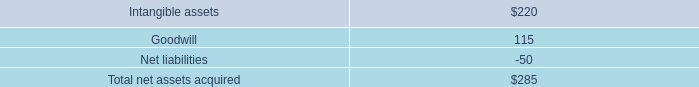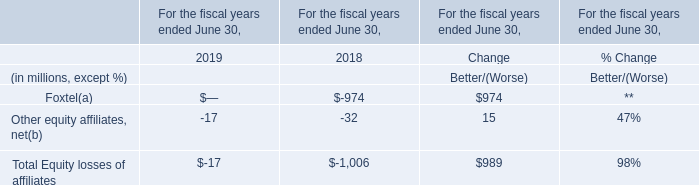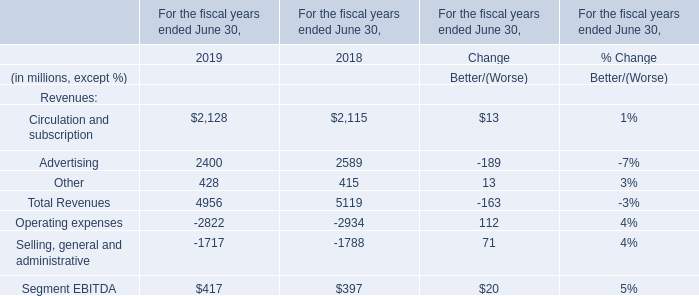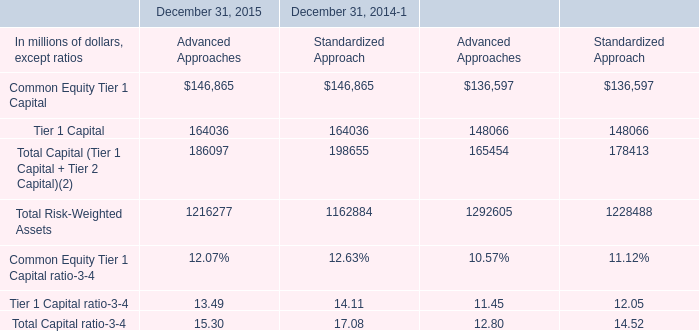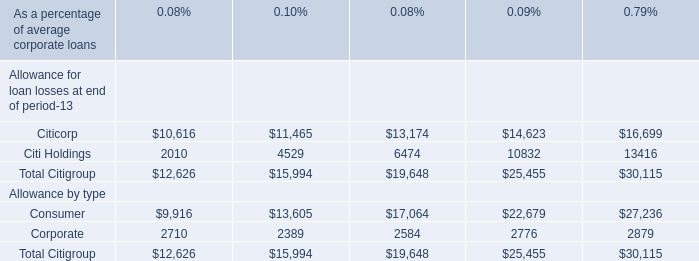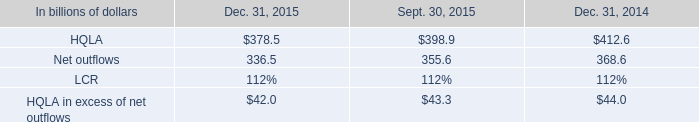In the year with the most Circulation and subscription, what is the growth rate of Total Revenues? 
Computations: ((4956 + 5119) / 4956)
Answer: 2.03289. 